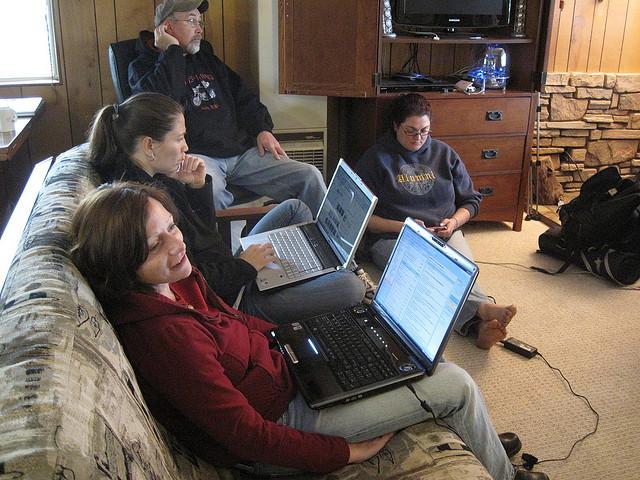How many laptops can be seen?
Be succinct. 2. Is the woman in red running her computer on battery power?
Give a very brief answer. No. How many people are in the picture?
Concise answer only. 4. 